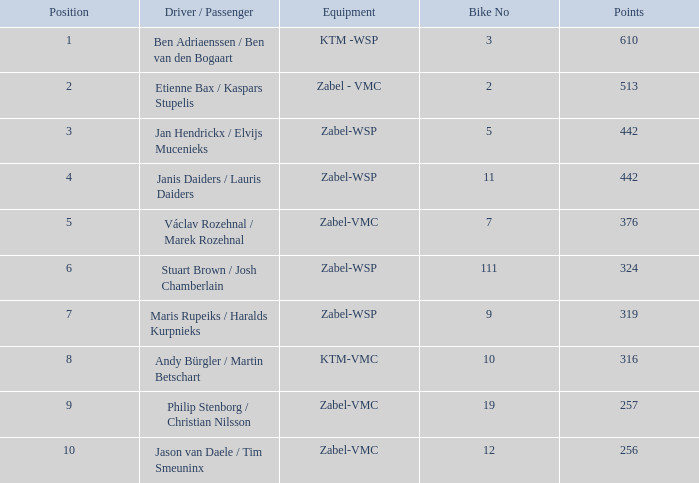What is the device having a points value below 442 and a placement of 9? Zabel-VMC. 